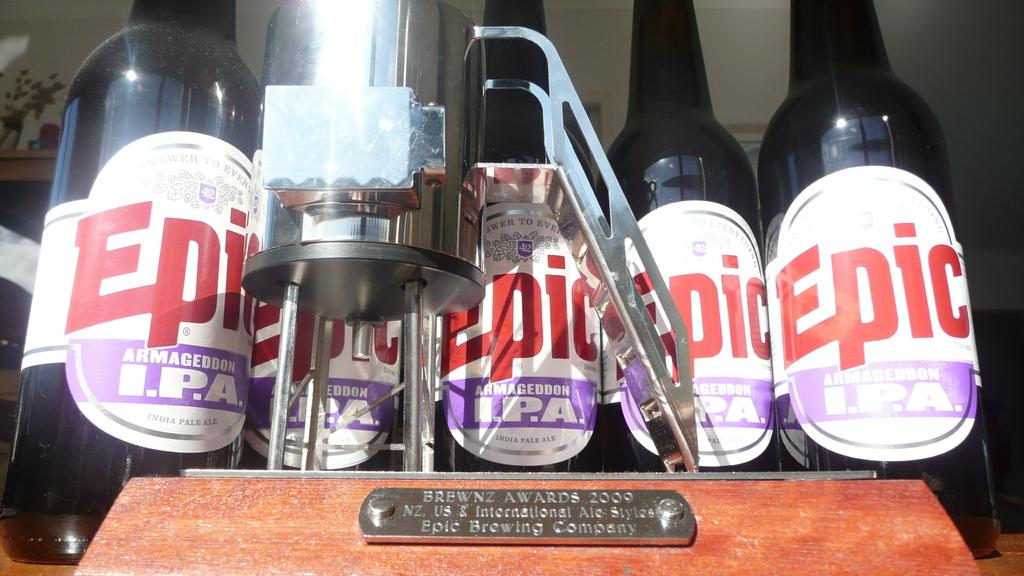<image>
Share a concise interpretation of the image provided. Bottles with the brand name Epic are lined up. 